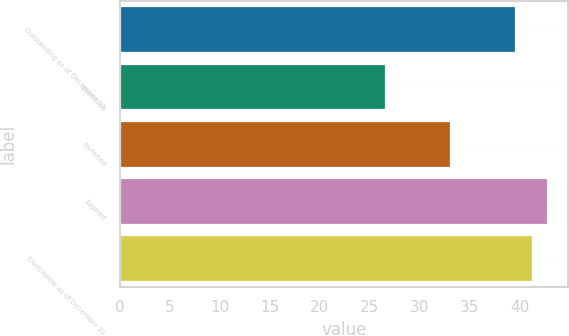<chart> <loc_0><loc_0><loc_500><loc_500><bar_chart><fcel>Outstanding as of December 31<fcel>Exercised<fcel>Forfeited<fcel>Expired<fcel>Exercisable as of December 31<nl><fcel>39.49<fcel>26.5<fcel>33.07<fcel>42.72<fcel>41.2<nl></chart> 